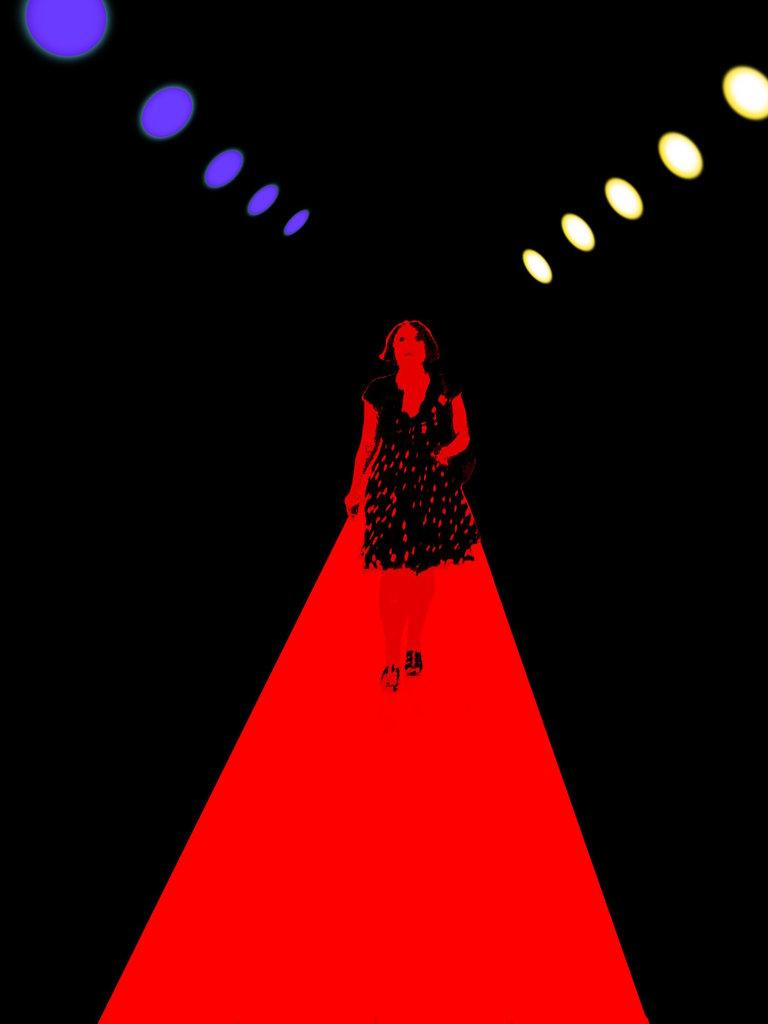Who is the main subject in the image? There is a lady in the image. What is the lady doing in the image? The lady is walking on a red color platform. What is the color of the background in the image? The background of the image is black. What else can be seen in the image besides the lady and the platform? There are lights visible in the image. What type of knife is the lady holding in the image? There is no knife present in the image. What achievements has the lady accomplished, as seen in the image? The image does not provide any information about the lady's achievements. 